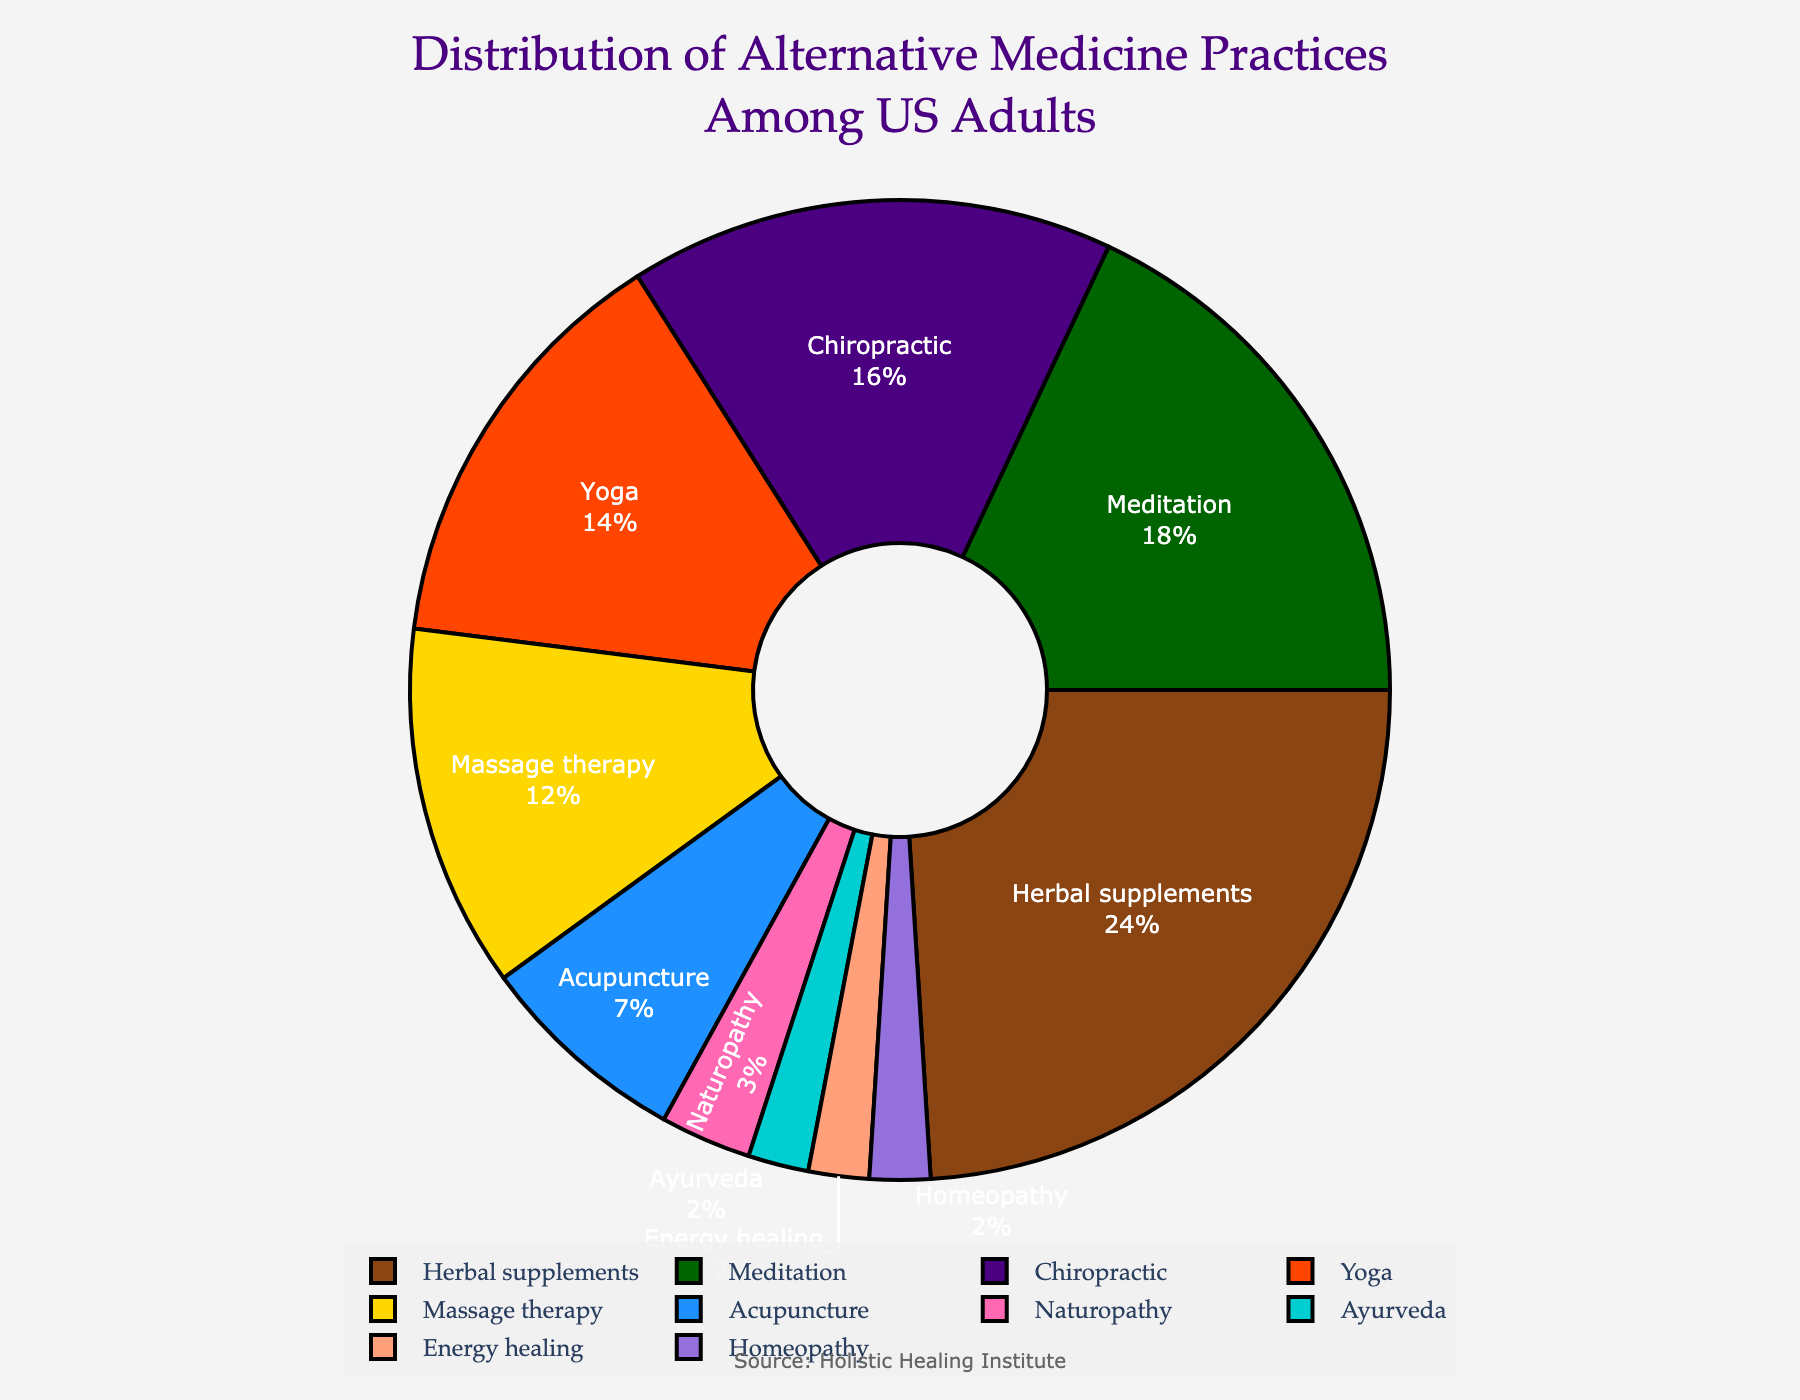What's the largest category of alternative medicine practices among US adults? The largest segment on the pie chart by percentage represents Herbal supplements which occupy 24% of the total.
Answer: Herbal supplements Which practice has a higher percentage, Chiropractic or Massage therapy? Comparing the two segments, Chiropractic holds 16% while Massage therapy holds 12%, so Chiropractic has a higher percentage.
Answer: Chiropractic What is the combined percentage of Naturopathy, Ayurveda, Energy healing, and Homeopathy? Adding the percentages: Naturopathy (3%) + Ayurveda (2%) + Energy healing (2%) + Homeopathy (2%) equals a total of 9%.
Answer: 9% How much more popular is Yoga compared to Acupuncture? Subtracting the percentage of Acupuncture (7%) from Yoga (14%) results in a difference of 7%.
Answer: 7% Which two practices combined make up exactly 30% of the distribution? Herbal supplements (24%) and Naturopathy (3%) together make 27%, while Chiropractic (16%) and Meditation (18%) add up to 34%, etc. The correct pair is Meditation (18%) and Massage therapy (12%), which sum to 30%.
Answer: Meditation and Massage therapy What practice is depicted with the golden color, and what is its percentage? The golden color in the pie chart corresponds to Massage therapy which has a percentage of 12%.
Answer: Massage therapy, 12% How does the percentage of Meditation compare to the sum of Ayurveda and Homeopathy? Meditation has 18%, while Ayurveda and Homeopathy together sum to 4% (2% + 2%). Thus, Meditation is much higher.
Answer: Meditation is higher What is the total percentage represented by the top three practices? Adding the percentages of the top three practices: Herbal supplements (24%), Meditation (18%), and Chiropractic (16%) equals a total of 58%.
Answer: 58% Does Energy healing or Homeopathy have a larger share, or are they equal? Both Energy healing and Homeopathy hold each 2% of the distribution, meaning they are equal.
Answer: Equal Which practice(s) occupy a smaller segment than Naturopathy? Naturopathy holds 3%, which is larger than the percentage of Ayurveda (2%), Energy healing (2%), and Homeopathy (2%).
Answer: Ayurveda, Energy healing, Homeopathy 